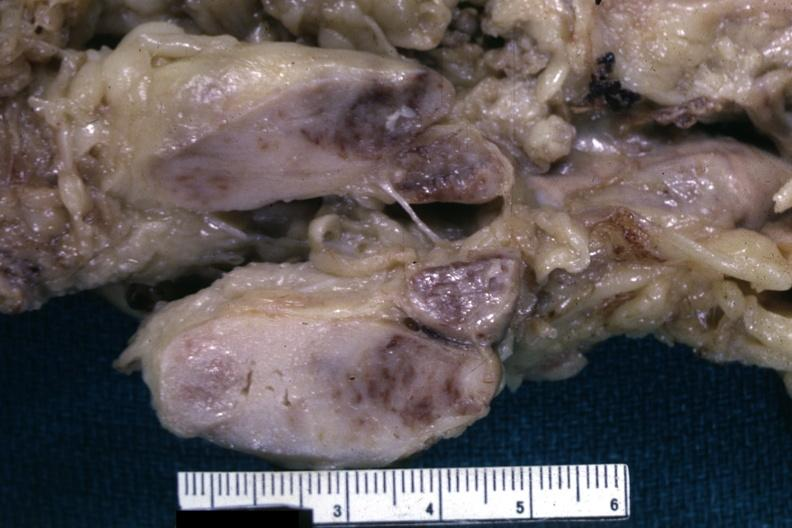s malignant lymphoma present?
Answer the question using a single word or phrase. Yes 